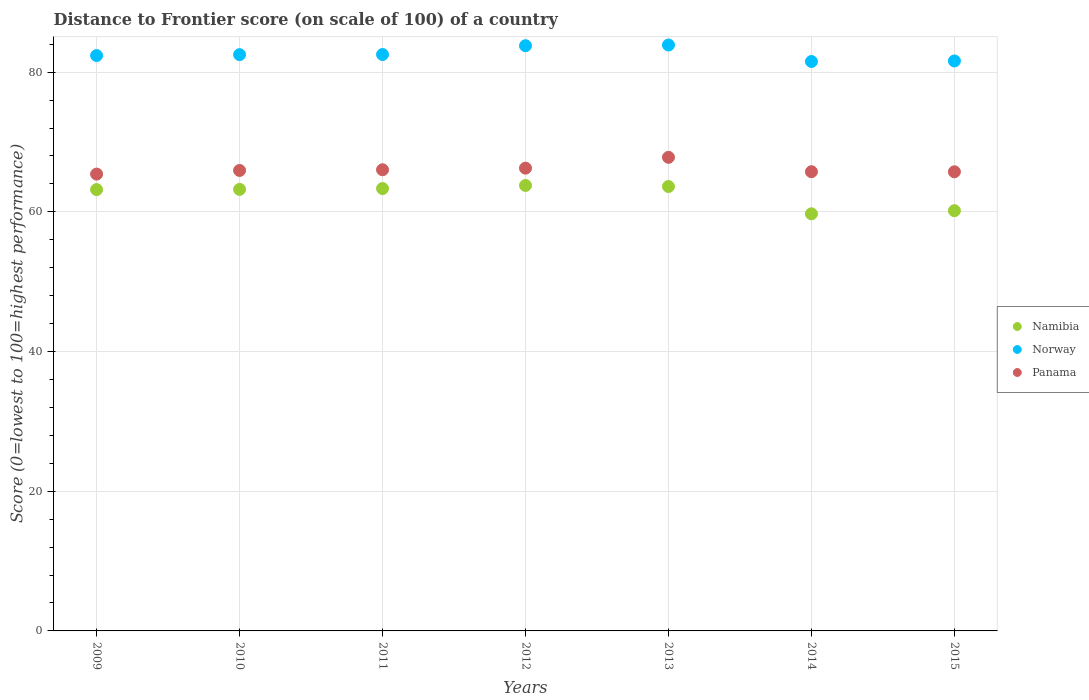How many different coloured dotlines are there?
Provide a succinct answer. 3. Is the number of dotlines equal to the number of legend labels?
Your response must be concise. Yes. What is the distance to frontier score of in Norway in 2013?
Your answer should be compact. 83.89. Across all years, what is the maximum distance to frontier score of in Panama?
Offer a terse response. 67.81. Across all years, what is the minimum distance to frontier score of in Namibia?
Your answer should be compact. 59.72. In which year was the distance to frontier score of in Namibia maximum?
Give a very brief answer. 2012. In which year was the distance to frontier score of in Namibia minimum?
Your answer should be compact. 2014. What is the total distance to frontier score of in Panama in the graph?
Keep it short and to the point. 462.93. What is the difference between the distance to frontier score of in Namibia in 2009 and that in 2015?
Ensure brevity in your answer.  3.02. What is the difference between the distance to frontier score of in Namibia in 2011 and the distance to frontier score of in Norway in 2015?
Ensure brevity in your answer.  -18.27. What is the average distance to frontier score of in Panama per year?
Provide a short and direct response. 66.13. In the year 2015, what is the difference between the distance to frontier score of in Panama and distance to frontier score of in Namibia?
Give a very brief answer. 5.57. What is the ratio of the distance to frontier score of in Norway in 2012 to that in 2013?
Give a very brief answer. 1. Is the difference between the distance to frontier score of in Panama in 2013 and 2014 greater than the difference between the distance to frontier score of in Namibia in 2013 and 2014?
Offer a terse response. No. What is the difference between the highest and the second highest distance to frontier score of in Norway?
Offer a terse response. 0.1. What is the difference between the highest and the lowest distance to frontier score of in Norway?
Offer a terse response. 2.36. In how many years, is the distance to frontier score of in Norway greater than the average distance to frontier score of in Norway taken over all years?
Provide a short and direct response. 2. Is the sum of the distance to frontier score of in Namibia in 2009 and 2010 greater than the maximum distance to frontier score of in Panama across all years?
Your answer should be compact. Yes. Does the distance to frontier score of in Norway monotonically increase over the years?
Give a very brief answer. No. How many dotlines are there?
Offer a very short reply. 3. How many years are there in the graph?
Your response must be concise. 7. Does the graph contain any zero values?
Provide a short and direct response. No. Where does the legend appear in the graph?
Ensure brevity in your answer.  Center right. How many legend labels are there?
Provide a succinct answer. 3. What is the title of the graph?
Provide a succinct answer. Distance to Frontier score (on scale of 100) of a country. What is the label or title of the Y-axis?
Your answer should be very brief. Score (0=lowest to 100=highest performance). What is the Score (0=lowest to 100=highest performance) of Namibia in 2009?
Your answer should be compact. 63.19. What is the Score (0=lowest to 100=highest performance) in Norway in 2009?
Offer a terse response. 82.38. What is the Score (0=lowest to 100=highest performance) in Panama in 2009?
Make the answer very short. 65.41. What is the Score (0=lowest to 100=highest performance) in Namibia in 2010?
Make the answer very short. 63.22. What is the Score (0=lowest to 100=highest performance) in Norway in 2010?
Keep it short and to the point. 82.51. What is the Score (0=lowest to 100=highest performance) in Panama in 2010?
Make the answer very short. 65.93. What is the Score (0=lowest to 100=highest performance) of Namibia in 2011?
Offer a very short reply. 63.34. What is the Score (0=lowest to 100=highest performance) in Norway in 2011?
Keep it short and to the point. 82.53. What is the Score (0=lowest to 100=highest performance) of Panama in 2011?
Offer a very short reply. 66.03. What is the Score (0=lowest to 100=highest performance) of Namibia in 2012?
Offer a terse response. 63.78. What is the Score (0=lowest to 100=highest performance) in Norway in 2012?
Provide a short and direct response. 83.79. What is the Score (0=lowest to 100=highest performance) of Panama in 2012?
Ensure brevity in your answer.  66.26. What is the Score (0=lowest to 100=highest performance) in Namibia in 2013?
Offer a very short reply. 63.63. What is the Score (0=lowest to 100=highest performance) in Norway in 2013?
Provide a short and direct response. 83.89. What is the Score (0=lowest to 100=highest performance) in Panama in 2013?
Offer a very short reply. 67.81. What is the Score (0=lowest to 100=highest performance) of Namibia in 2014?
Ensure brevity in your answer.  59.72. What is the Score (0=lowest to 100=highest performance) of Norway in 2014?
Offer a very short reply. 81.53. What is the Score (0=lowest to 100=highest performance) of Panama in 2014?
Offer a terse response. 65.75. What is the Score (0=lowest to 100=highest performance) of Namibia in 2015?
Keep it short and to the point. 60.17. What is the Score (0=lowest to 100=highest performance) of Norway in 2015?
Provide a succinct answer. 81.61. What is the Score (0=lowest to 100=highest performance) of Panama in 2015?
Provide a succinct answer. 65.74. Across all years, what is the maximum Score (0=lowest to 100=highest performance) in Namibia?
Ensure brevity in your answer.  63.78. Across all years, what is the maximum Score (0=lowest to 100=highest performance) in Norway?
Provide a succinct answer. 83.89. Across all years, what is the maximum Score (0=lowest to 100=highest performance) in Panama?
Ensure brevity in your answer.  67.81. Across all years, what is the minimum Score (0=lowest to 100=highest performance) of Namibia?
Provide a short and direct response. 59.72. Across all years, what is the minimum Score (0=lowest to 100=highest performance) in Norway?
Provide a succinct answer. 81.53. Across all years, what is the minimum Score (0=lowest to 100=highest performance) of Panama?
Provide a short and direct response. 65.41. What is the total Score (0=lowest to 100=highest performance) in Namibia in the graph?
Provide a succinct answer. 437.05. What is the total Score (0=lowest to 100=highest performance) of Norway in the graph?
Ensure brevity in your answer.  578.24. What is the total Score (0=lowest to 100=highest performance) in Panama in the graph?
Provide a short and direct response. 462.93. What is the difference between the Score (0=lowest to 100=highest performance) of Namibia in 2009 and that in 2010?
Keep it short and to the point. -0.03. What is the difference between the Score (0=lowest to 100=highest performance) in Norway in 2009 and that in 2010?
Offer a terse response. -0.13. What is the difference between the Score (0=lowest to 100=highest performance) in Panama in 2009 and that in 2010?
Your response must be concise. -0.52. What is the difference between the Score (0=lowest to 100=highest performance) of Namibia in 2009 and that in 2011?
Ensure brevity in your answer.  -0.15. What is the difference between the Score (0=lowest to 100=highest performance) in Norway in 2009 and that in 2011?
Provide a succinct answer. -0.15. What is the difference between the Score (0=lowest to 100=highest performance) of Panama in 2009 and that in 2011?
Provide a succinct answer. -0.62. What is the difference between the Score (0=lowest to 100=highest performance) of Namibia in 2009 and that in 2012?
Your answer should be compact. -0.59. What is the difference between the Score (0=lowest to 100=highest performance) of Norway in 2009 and that in 2012?
Provide a short and direct response. -1.41. What is the difference between the Score (0=lowest to 100=highest performance) of Panama in 2009 and that in 2012?
Ensure brevity in your answer.  -0.85. What is the difference between the Score (0=lowest to 100=highest performance) of Namibia in 2009 and that in 2013?
Make the answer very short. -0.44. What is the difference between the Score (0=lowest to 100=highest performance) of Norway in 2009 and that in 2013?
Offer a terse response. -1.51. What is the difference between the Score (0=lowest to 100=highest performance) of Panama in 2009 and that in 2013?
Keep it short and to the point. -2.4. What is the difference between the Score (0=lowest to 100=highest performance) in Namibia in 2009 and that in 2014?
Ensure brevity in your answer.  3.47. What is the difference between the Score (0=lowest to 100=highest performance) of Panama in 2009 and that in 2014?
Offer a terse response. -0.34. What is the difference between the Score (0=lowest to 100=highest performance) in Namibia in 2009 and that in 2015?
Ensure brevity in your answer.  3.02. What is the difference between the Score (0=lowest to 100=highest performance) in Norway in 2009 and that in 2015?
Your response must be concise. 0.77. What is the difference between the Score (0=lowest to 100=highest performance) of Panama in 2009 and that in 2015?
Provide a succinct answer. -0.33. What is the difference between the Score (0=lowest to 100=highest performance) in Namibia in 2010 and that in 2011?
Give a very brief answer. -0.12. What is the difference between the Score (0=lowest to 100=highest performance) in Norway in 2010 and that in 2011?
Your answer should be very brief. -0.02. What is the difference between the Score (0=lowest to 100=highest performance) of Namibia in 2010 and that in 2012?
Offer a terse response. -0.56. What is the difference between the Score (0=lowest to 100=highest performance) of Norway in 2010 and that in 2012?
Your answer should be compact. -1.28. What is the difference between the Score (0=lowest to 100=highest performance) of Panama in 2010 and that in 2012?
Offer a very short reply. -0.33. What is the difference between the Score (0=lowest to 100=highest performance) of Namibia in 2010 and that in 2013?
Make the answer very short. -0.41. What is the difference between the Score (0=lowest to 100=highest performance) in Norway in 2010 and that in 2013?
Ensure brevity in your answer.  -1.38. What is the difference between the Score (0=lowest to 100=highest performance) in Panama in 2010 and that in 2013?
Your answer should be very brief. -1.88. What is the difference between the Score (0=lowest to 100=highest performance) in Namibia in 2010 and that in 2014?
Your answer should be compact. 3.5. What is the difference between the Score (0=lowest to 100=highest performance) in Panama in 2010 and that in 2014?
Make the answer very short. 0.18. What is the difference between the Score (0=lowest to 100=highest performance) of Namibia in 2010 and that in 2015?
Give a very brief answer. 3.05. What is the difference between the Score (0=lowest to 100=highest performance) in Norway in 2010 and that in 2015?
Give a very brief answer. 0.9. What is the difference between the Score (0=lowest to 100=highest performance) in Panama in 2010 and that in 2015?
Give a very brief answer. 0.19. What is the difference between the Score (0=lowest to 100=highest performance) of Namibia in 2011 and that in 2012?
Provide a short and direct response. -0.44. What is the difference between the Score (0=lowest to 100=highest performance) of Norway in 2011 and that in 2012?
Ensure brevity in your answer.  -1.26. What is the difference between the Score (0=lowest to 100=highest performance) in Panama in 2011 and that in 2012?
Offer a terse response. -0.23. What is the difference between the Score (0=lowest to 100=highest performance) of Namibia in 2011 and that in 2013?
Your answer should be very brief. -0.29. What is the difference between the Score (0=lowest to 100=highest performance) in Norway in 2011 and that in 2013?
Keep it short and to the point. -1.36. What is the difference between the Score (0=lowest to 100=highest performance) in Panama in 2011 and that in 2013?
Provide a succinct answer. -1.78. What is the difference between the Score (0=lowest to 100=highest performance) of Namibia in 2011 and that in 2014?
Offer a very short reply. 3.62. What is the difference between the Score (0=lowest to 100=highest performance) in Norway in 2011 and that in 2014?
Your answer should be very brief. 1. What is the difference between the Score (0=lowest to 100=highest performance) of Panama in 2011 and that in 2014?
Make the answer very short. 0.28. What is the difference between the Score (0=lowest to 100=highest performance) in Namibia in 2011 and that in 2015?
Ensure brevity in your answer.  3.17. What is the difference between the Score (0=lowest to 100=highest performance) of Panama in 2011 and that in 2015?
Your answer should be compact. 0.29. What is the difference between the Score (0=lowest to 100=highest performance) in Namibia in 2012 and that in 2013?
Offer a terse response. 0.15. What is the difference between the Score (0=lowest to 100=highest performance) in Norway in 2012 and that in 2013?
Offer a very short reply. -0.1. What is the difference between the Score (0=lowest to 100=highest performance) in Panama in 2012 and that in 2013?
Keep it short and to the point. -1.55. What is the difference between the Score (0=lowest to 100=highest performance) in Namibia in 2012 and that in 2014?
Make the answer very short. 4.06. What is the difference between the Score (0=lowest to 100=highest performance) in Norway in 2012 and that in 2014?
Your response must be concise. 2.26. What is the difference between the Score (0=lowest to 100=highest performance) in Panama in 2012 and that in 2014?
Keep it short and to the point. 0.51. What is the difference between the Score (0=lowest to 100=highest performance) of Namibia in 2012 and that in 2015?
Provide a short and direct response. 3.61. What is the difference between the Score (0=lowest to 100=highest performance) of Norway in 2012 and that in 2015?
Make the answer very short. 2.18. What is the difference between the Score (0=lowest to 100=highest performance) in Panama in 2012 and that in 2015?
Offer a very short reply. 0.52. What is the difference between the Score (0=lowest to 100=highest performance) of Namibia in 2013 and that in 2014?
Ensure brevity in your answer.  3.91. What is the difference between the Score (0=lowest to 100=highest performance) of Norway in 2013 and that in 2014?
Give a very brief answer. 2.36. What is the difference between the Score (0=lowest to 100=highest performance) of Panama in 2013 and that in 2014?
Offer a very short reply. 2.06. What is the difference between the Score (0=lowest to 100=highest performance) of Namibia in 2013 and that in 2015?
Offer a very short reply. 3.46. What is the difference between the Score (0=lowest to 100=highest performance) in Norway in 2013 and that in 2015?
Provide a succinct answer. 2.28. What is the difference between the Score (0=lowest to 100=highest performance) of Panama in 2013 and that in 2015?
Your answer should be compact. 2.07. What is the difference between the Score (0=lowest to 100=highest performance) in Namibia in 2014 and that in 2015?
Provide a succinct answer. -0.45. What is the difference between the Score (0=lowest to 100=highest performance) in Norway in 2014 and that in 2015?
Your answer should be compact. -0.08. What is the difference between the Score (0=lowest to 100=highest performance) in Panama in 2014 and that in 2015?
Offer a terse response. 0.01. What is the difference between the Score (0=lowest to 100=highest performance) in Namibia in 2009 and the Score (0=lowest to 100=highest performance) in Norway in 2010?
Keep it short and to the point. -19.32. What is the difference between the Score (0=lowest to 100=highest performance) of Namibia in 2009 and the Score (0=lowest to 100=highest performance) of Panama in 2010?
Your answer should be very brief. -2.74. What is the difference between the Score (0=lowest to 100=highest performance) of Norway in 2009 and the Score (0=lowest to 100=highest performance) of Panama in 2010?
Your answer should be compact. 16.45. What is the difference between the Score (0=lowest to 100=highest performance) in Namibia in 2009 and the Score (0=lowest to 100=highest performance) in Norway in 2011?
Your answer should be compact. -19.34. What is the difference between the Score (0=lowest to 100=highest performance) in Namibia in 2009 and the Score (0=lowest to 100=highest performance) in Panama in 2011?
Provide a succinct answer. -2.84. What is the difference between the Score (0=lowest to 100=highest performance) in Norway in 2009 and the Score (0=lowest to 100=highest performance) in Panama in 2011?
Make the answer very short. 16.35. What is the difference between the Score (0=lowest to 100=highest performance) in Namibia in 2009 and the Score (0=lowest to 100=highest performance) in Norway in 2012?
Provide a short and direct response. -20.6. What is the difference between the Score (0=lowest to 100=highest performance) in Namibia in 2009 and the Score (0=lowest to 100=highest performance) in Panama in 2012?
Ensure brevity in your answer.  -3.07. What is the difference between the Score (0=lowest to 100=highest performance) of Norway in 2009 and the Score (0=lowest to 100=highest performance) of Panama in 2012?
Keep it short and to the point. 16.12. What is the difference between the Score (0=lowest to 100=highest performance) of Namibia in 2009 and the Score (0=lowest to 100=highest performance) of Norway in 2013?
Offer a very short reply. -20.7. What is the difference between the Score (0=lowest to 100=highest performance) of Namibia in 2009 and the Score (0=lowest to 100=highest performance) of Panama in 2013?
Keep it short and to the point. -4.62. What is the difference between the Score (0=lowest to 100=highest performance) in Norway in 2009 and the Score (0=lowest to 100=highest performance) in Panama in 2013?
Make the answer very short. 14.57. What is the difference between the Score (0=lowest to 100=highest performance) of Namibia in 2009 and the Score (0=lowest to 100=highest performance) of Norway in 2014?
Offer a very short reply. -18.34. What is the difference between the Score (0=lowest to 100=highest performance) of Namibia in 2009 and the Score (0=lowest to 100=highest performance) of Panama in 2014?
Provide a short and direct response. -2.56. What is the difference between the Score (0=lowest to 100=highest performance) in Norway in 2009 and the Score (0=lowest to 100=highest performance) in Panama in 2014?
Ensure brevity in your answer.  16.63. What is the difference between the Score (0=lowest to 100=highest performance) in Namibia in 2009 and the Score (0=lowest to 100=highest performance) in Norway in 2015?
Provide a short and direct response. -18.42. What is the difference between the Score (0=lowest to 100=highest performance) in Namibia in 2009 and the Score (0=lowest to 100=highest performance) in Panama in 2015?
Your response must be concise. -2.55. What is the difference between the Score (0=lowest to 100=highest performance) in Norway in 2009 and the Score (0=lowest to 100=highest performance) in Panama in 2015?
Your answer should be compact. 16.64. What is the difference between the Score (0=lowest to 100=highest performance) in Namibia in 2010 and the Score (0=lowest to 100=highest performance) in Norway in 2011?
Your answer should be compact. -19.31. What is the difference between the Score (0=lowest to 100=highest performance) of Namibia in 2010 and the Score (0=lowest to 100=highest performance) of Panama in 2011?
Your response must be concise. -2.81. What is the difference between the Score (0=lowest to 100=highest performance) in Norway in 2010 and the Score (0=lowest to 100=highest performance) in Panama in 2011?
Your answer should be very brief. 16.48. What is the difference between the Score (0=lowest to 100=highest performance) of Namibia in 2010 and the Score (0=lowest to 100=highest performance) of Norway in 2012?
Provide a succinct answer. -20.57. What is the difference between the Score (0=lowest to 100=highest performance) of Namibia in 2010 and the Score (0=lowest to 100=highest performance) of Panama in 2012?
Provide a short and direct response. -3.04. What is the difference between the Score (0=lowest to 100=highest performance) in Norway in 2010 and the Score (0=lowest to 100=highest performance) in Panama in 2012?
Your answer should be very brief. 16.25. What is the difference between the Score (0=lowest to 100=highest performance) in Namibia in 2010 and the Score (0=lowest to 100=highest performance) in Norway in 2013?
Keep it short and to the point. -20.67. What is the difference between the Score (0=lowest to 100=highest performance) in Namibia in 2010 and the Score (0=lowest to 100=highest performance) in Panama in 2013?
Provide a succinct answer. -4.59. What is the difference between the Score (0=lowest to 100=highest performance) in Norway in 2010 and the Score (0=lowest to 100=highest performance) in Panama in 2013?
Provide a short and direct response. 14.7. What is the difference between the Score (0=lowest to 100=highest performance) in Namibia in 2010 and the Score (0=lowest to 100=highest performance) in Norway in 2014?
Offer a terse response. -18.31. What is the difference between the Score (0=lowest to 100=highest performance) of Namibia in 2010 and the Score (0=lowest to 100=highest performance) of Panama in 2014?
Keep it short and to the point. -2.53. What is the difference between the Score (0=lowest to 100=highest performance) in Norway in 2010 and the Score (0=lowest to 100=highest performance) in Panama in 2014?
Your answer should be compact. 16.76. What is the difference between the Score (0=lowest to 100=highest performance) in Namibia in 2010 and the Score (0=lowest to 100=highest performance) in Norway in 2015?
Provide a short and direct response. -18.39. What is the difference between the Score (0=lowest to 100=highest performance) in Namibia in 2010 and the Score (0=lowest to 100=highest performance) in Panama in 2015?
Make the answer very short. -2.52. What is the difference between the Score (0=lowest to 100=highest performance) in Norway in 2010 and the Score (0=lowest to 100=highest performance) in Panama in 2015?
Your answer should be compact. 16.77. What is the difference between the Score (0=lowest to 100=highest performance) in Namibia in 2011 and the Score (0=lowest to 100=highest performance) in Norway in 2012?
Your answer should be compact. -20.45. What is the difference between the Score (0=lowest to 100=highest performance) of Namibia in 2011 and the Score (0=lowest to 100=highest performance) of Panama in 2012?
Offer a very short reply. -2.92. What is the difference between the Score (0=lowest to 100=highest performance) of Norway in 2011 and the Score (0=lowest to 100=highest performance) of Panama in 2012?
Your answer should be very brief. 16.27. What is the difference between the Score (0=lowest to 100=highest performance) of Namibia in 2011 and the Score (0=lowest to 100=highest performance) of Norway in 2013?
Provide a short and direct response. -20.55. What is the difference between the Score (0=lowest to 100=highest performance) of Namibia in 2011 and the Score (0=lowest to 100=highest performance) of Panama in 2013?
Offer a terse response. -4.47. What is the difference between the Score (0=lowest to 100=highest performance) of Norway in 2011 and the Score (0=lowest to 100=highest performance) of Panama in 2013?
Your answer should be very brief. 14.72. What is the difference between the Score (0=lowest to 100=highest performance) in Namibia in 2011 and the Score (0=lowest to 100=highest performance) in Norway in 2014?
Your response must be concise. -18.19. What is the difference between the Score (0=lowest to 100=highest performance) of Namibia in 2011 and the Score (0=lowest to 100=highest performance) of Panama in 2014?
Provide a succinct answer. -2.41. What is the difference between the Score (0=lowest to 100=highest performance) of Norway in 2011 and the Score (0=lowest to 100=highest performance) of Panama in 2014?
Keep it short and to the point. 16.78. What is the difference between the Score (0=lowest to 100=highest performance) in Namibia in 2011 and the Score (0=lowest to 100=highest performance) in Norway in 2015?
Offer a very short reply. -18.27. What is the difference between the Score (0=lowest to 100=highest performance) in Norway in 2011 and the Score (0=lowest to 100=highest performance) in Panama in 2015?
Keep it short and to the point. 16.79. What is the difference between the Score (0=lowest to 100=highest performance) of Namibia in 2012 and the Score (0=lowest to 100=highest performance) of Norway in 2013?
Provide a succinct answer. -20.11. What is the difference between the Score (0=lowest to 100=highest performance) of Namibia in 2012 and the Score (0=lowest to 100=highest performance) of Panama in 2013?
Provide a short and direct response. -4.03. What is the difference between the Score (0=lowest to 100=highest performance) of Norway in 2012 and the Score (0=lowest to 100=highest performance) of Panama in 2013?
Keep it short and to the point. 15.98. What is the difference between the Score (0=lowest to 100=highest performance) of Namibia in 2012 and the Score (0=lowest to 100=highest performance) of Norway in 2014?
Make the answer very short. -17.75. What is the difference between the Score (0=lowest to 100=highest performance) of Namibia in 2012 and the Score (0=lowest to 100=highest performance) of Panama in 2014?
Offer a terse response. -1.97. What is the difference between the Score (0=lowest to 100=highest performance) of Norway in 2012 and the Score (0=lowest to 100=highest performance) of Panama in 2014?
Offer a terse response. 18.04. What is the difference between the Score (0=lowest to 100=highest performance) in Namibia in 2012 and the Score (0=lowest to 100=highest performance) in Norway in 2015?
Make the answer very short. -17.83. What is the difference between the Score (0=lowest to 100=highest performance) in Namibia in 2012 and the Score (0=lowest to 100=highest performance) in Panama in 2015?
Keep it short and to the point. -1.96. What is the difference between the Score (0=lowest to 100=highest performance) in Norway in 2012 and the Score (0=lowest to 100=highest performance) in Panama in 2015?
Ensure brevity in your answer.  18.05. What is the difference between the Score (0=lowest to 100=highest performance) of Namibia in 2013 and the Score (0=lowest to 100=highest performance) of Norway in 2014?
Offer a very short reply. -17.9. What is the difference between the Score (0=lowest to 100=highest performance) in Namibia in 2013 and the Score (0=lowest to 100=highest performance) in Panama in 2014?
Provide a succinct answer. -2.12. What is the difference between the Score (0=lowest to 100=highest performance) of Norway in 2013 and the Score (0=lowest to 100=highest performance) of Panama in 2014?
Offer a terse response. 18.14. What is the difference between the Score (0=lowest to 100=highest performance) in Namibia in 2013 and the Score (0=lowest to 100=highest performance) in Norway in 2015?
Offer a terse response. -17.98. What is the difference between the Score (0=lowest to 100=highest performance) of Namibia in 2013 and the Score (0=lowest to 100=highest performance) of Panama in 2015?
Provide a short and direct response. -2.11. What is the difference between the Score (0=lowest to 100=highest performance) in Norway in 2013 and the Score (0=lowest to 100=highest performance) in Panama in 2015?
Provide a short and direct response. 18.15. What is the difference between the Score (0=lowest to 100=highest performance) of Namibia in 2014 and the Score (0=lowest to 100=highest performance) of Norway in 2015?
Offer a very short reply. -21.89. What is the difference between the Score (0=lowest to 100=highest performance) of Namibia in 2014 and the Score (0=lowest to 100=highest performance) of Panama in 2015?
Keep it short and to the point. -6.02. What is the difference between the Score (0=lowest to 100=highest performance) of Norway in 2014 and the Score (0=lowest to 100=highest performance) of Panama in 2015?
Provide a succinct answer. 15.79. What is the average Score (0=lowest to 100=highest performance) in Namibia per year?
Make the answer very short. 62.44. What is the average Score (0=lowest to 100=highest performance) in Norway per year?
Ensure brevity in your answer.  82.61. What is the average Score (0=lowest to 100=highest performance) in Panama per year?
Give a very brief answer. 66.13. In the year 2009, what is the difference between the Score (0=lowest to 100=highest performance) of Namibia and Score (0=lowest to 100=highest performance) of Norway?
Keep it short and to the point. -19.19. In the year 2009, what is the difference between the Score (0=lowest to 100=highest performance) in Namibia and Score (0=lowest to 100=highest performance) in Panama?
Your answer should be very brief. -2.22. In the year 2009, what is the difference between the Score (0=lowest to 100=highest performance) in Norway and Score (0=lowest to 100=highest performance) in Panama?
Provide a succinct answer. 16.97. In the year 2010, what is the difference between the Score (0=lowest to 100=highest performance) of Namibia and Score (0=lowest to 100=highest performance) of Norway?
Your answer should be compact. -19.29. In the year 2010, what is the difference between the Score (0=lowest to 100=highest performance) of Namibia and Score (0=lowest to 100=highest performance) of Panama?
Give a very brief answer. -2.71. In the year 2010, what is the difference between the Score (0=lowest to 100=highest performance) of Norway and Score (0=lowest to 100=highest performance) of Panama?
Your answer should be compact. 16.58. In the year 2011, what is the difference between the Score (0=lowest to 100=highest performance) in Namibia and Score (0=lowest to 100=highest performance) in Norway?
Ensure brevity in your answer.  -19.19. In the year 2011, what is the difference between the Score (0=lowest to 100=highest performance) in Namibia and Score (0=lowest to 100=highest performance) in Panama?
Offer a terse response. -2.69. In the year 2012, what is the difference between the Score (0=lowest to 100=highest performance) in Namibia and Score (0=lowest to 100=highest performance) in Norway?
Your answer should be very brief. -20.01. In the year 2012, what is the difference between the Score (0=lowest to 100=highest performance) of Namibia and Score (0=lowest to 100=highest performance) of Panama?
Give a very brief answer. -2.48. In the year 2012, what is the difference between the Score (0=lowest to 100=highest performance) of Norway and Score (0=lowest to 100=highest performance) of Panama?
Make the answer very short. 17.53. In the year 2013, what is the difference between the Score (0=lowest to 100=highest performance) in Namibia and Score (0=lowest to 100=highest performance) in Norway?
Give a very brief answer. -20.26. In the year 2013, what is the difference between the Score (0=lowest to 100=highest performance) in Namibia and Score (0=lowest to 100=highest performance) in Panama?
Your answer should be compact. -4.18. In the year 2013, what is the difference between the Score (0=lowest to 100=highest performance) in Norway and Score (0=lowest to 100=highest performance) in Panama?
Your answer should be compact. 16.08. In the year 2014, what is the difference between the Score (0=lowest to 100=highest performance) in Namibia and Score (0=lowest to 100=highest performance) in Norway?
Your response must be concise. -21.81. In the year 2014, what is the difference between the Score (0=lowest to 100=highest performance) of Namibia and Score (0=lowest to 100=highest performance) of Panama?
Make the answer very short. -6.03. In the year 2014, what is the difference between the Score (0=lowest to 100=highest performance) of Norway and Score (0=lowest to 100=highest performance) of Panama?
Offer a terse response. 15.78. In the year 2015, what is the difference between the Score (0=lowest to 100=highest performance) of Namibia and Score (0=lowest to 100=highest performance) of Norway?
Keep it short and to the point. -21.44. In the year 2015, what is the difference between the Score (0=lowest to 100=highest performance) of Namibia and Score (0=lowest to 100=highest performance) of Panama?
Offer a terse response. -5.57. In the year 2015, what is the difference between the Score (0=lowest to 100=highest performance) in Norway and Score (0=lowest to 100=highest performance) in Panama?
Make the answer very short. 15.87. What is the ratio of the Score (0=lowest to 100=highest performance) of Norway in 2009 to that in 2010?
Ensure brevity in your answer.  1. What is the ratio of the Score (0=lowest to 100=highest performance) in Panama in 2009 to that in 2010?
Make the answer very short. 0.99. What is the ratio of the Score (0=lowest to 100=highest performance) of Panama in 2009 to that in 2011?
Your answer should be compact. 0.99. What is the ratio of the Score (0=lowest to 100=highest performance) in Namibia in 2009 to that in 2012?
Give a very brief answer. 0.99. What is the ratio of the Score (0=lowest to 100=highest performance) of Norway in 2009 to that in 2012?
Make the answer very short. 0.98. What is the ratio of the Score (0=lowest to 100=highest performance) of Panama in 2009 to that in 2012?
Your answer should be compact. 0.99. What is the ratio of the Score (0=lowest to 100=highest performance) of Norway in 2009 to that in 2013?
Your response must be concise. 0.98. What is the ratio of the Score (0=lowest to 100=highest performance) of Panama in 2009 to that in 2013?
Keep it short and to the point. 0.96. What is the ratio of the Score (0=lowest to 100=highest performance) of Namibia in 2009 to that in 2014?
Your answer should be compact. 1.06. What is the ratio of the Score (0=lowest to 100=highest performance) in Norway in 2009 to that in 2014?
Your answer should be very brief. 1.01. What is the ratio of the Score (0=lowest to 100=highest performance) of Panama in 2009 to that in 2014?
Offer a terse response. 0.99. What is the ratio of the Score (0=lowest to 100=highest performance) of Namibia in 2009 to that in 2015?
Provide a short and direct response. 1.05. What is the ratio of the Score (0=lowest to 100=highest performance) of Norway in 2009 to that in 2015?
Keep it short and to the point. 1.01. What is the ratio of the Score (0=lowest to 100=highest performance) of Panama in 2009 to that in 2015?
Keep it short and to the point. 0.99. What is the ratio of the Score (0=lowest to 100=highest performance) in Norway in 2010 to that in 2011?
Your response must be concise. 1. What is the ratio of the Score (0=lowest to 100=highest performance) of Panama in 2010 to that in 2011?
Keep it short and to the point. 1. What is the ratio of the Score (0=lowest to 100=highest performance) in Namibia in 2010 to that in 2012?
Keep it short and to the point. 0.99. What is the ratio of the Score (0=lowest to 100=highest performance) of Norway in 2010 to that in 2012?
Ensure brevity in your answer.  0.98. What is the ratio of the Score (0=lowest to 100=highest performance) in Panama in 2010 to that in 2012?
Your answer should be very brief. 0.99. What is the ratio of the Score (0=lowest to 100=highest performance) of Namibia in 2010 to that in 2013?
Ensure brevity in your answer.  0.99. What is the ratio of the Score (0=lowest to 100=highest performance) of Norway in 2010 to that in 2013?
Offer a terse response. 0.98. What is the ratio of the Score (0=lowest to 100=highest performance) in Panama in 2010 to that in 2013?
Offer a terse response. 0.97. What is the ratio of the Score (0=lowest to 100=highest performance) in Namibia in 2010 to that in 2014?
Offer a very short reply. 1.06. What is the ratio of the Score (0=lowest to 100=highest performance) of Panama in 2010 to that in 2014?
Provide a succinct answer. 1. What is the ratio of the Score (0=lowest to 100=highest performance) in Namibia in 2010 to that in 2015?
Make the answer very short. 1.05. What is the ratio of the Score (0=lowest to 100=highest performance) in Norway in 2010 to that in 2015?
Offer a very short reply. 1.01. What is the ratio of the Score (0=lowest to 100=highest performance) of Panama in 2010 to that in 2015?
Provide a succinct answer. 1. What is the ratio of the Score (0=lowest to 100=highest performance) of Norway in 2011 to that in 2012?
Offer a terse response. 0.98. What is the ratio of the Score (0=lowest to 100=highest performance) in Panama in 2011 to that in 2012?
Keep it short and to the point. 1. What is the ratio of the Score (0=lowest to 100=highest performance) in Norway in 2011 to that in 2013?
Ensure brevity in your answer.  0.98. What is the ratio of the Score (0=lowest to 100=highest performance) of Panama in 2011 to that in 2013?
Your answer should be very brief. 0.97. What is the ratio of the Score (0=lowest to 100=highest performance) in Namibia in 2011 to that in 2014?
Provide a succinct answer. 1.06. What is the ratio of the Score (0=lowest to 100=highest performance) of Norway in 2011 to that in 2014?
Give a very brief answer. 1.01. What is the ratio of the Score (0=lowest to 100=highest performance) in Panama in 2011 to that in 2014?
Make the answer very short. 1. What is the ratio of the Score (0=lowest to 100=highest performance) of Namibia in 2011 to that in 2015?
Your response must be concise. 1.05. What is the ratio of the Score (0=lowest to 100=highest performance) of Norway in 2011 to that in 2015?
Ensure brevity in your answer.  1.01. What is the ratio of the Score (0=lowest to 100=highest performance) in Panama in 2011 to that in 2015?
Provide a succinct answer. 1. What is the ratio of the Score (0=lowest to 100=highest performance) of Norway in 2012 to that in 2013?
Provide a succinct answer. 1. What is the ratio of the Score (0=lowest to 100=highest performance) of Panama in 2012 to that in 2013?
Your answer should be compact. 0.98. What is the ratio of the Score (0=lowest to 100=highest performance) in Namibia in 2012 to that in 2014?
Your response must be concise. 1.07. What is the ratio of the Score (0=lowest to 100=highest performance) in Norway in 2012 to that in 2014?
Your answer should be compact. 1.03. What is the ratio of the Score (0=lowest to 100=highest performance) in Namibia in 2012 to that in 2015?
Your answer should be very brief. 1.06. What is the ratio of the Score (0=lowest to 100=highest performance) in Norway in 2012 to that in 2015?
Keep it short and to the point. 1.03. What is the ratio of the Score (0=lowest to 100=highest performance) in Panama in 2012 to that in 2015?
Your answer should be compact. 1.01. What is the ratio of the Score (0=lowest to 100=highest performance) of Namibia in 2013 to that in 2014?
Make the answer very short. 1.07. What is the ratio of the Score (0=lowest to 100=highest performance) in Norway in 2013 to that in 2014?
Provide a short and direct response. 1.03. What is the ratio of the Score (0=lowest to 100=highest performance) of Panama in 2013 to that in 2014?
Keep it short and to the point. 1.03. What is the ratio of the Score (0=lowest to 100=highest performance) in Namibia in 2013 to that in 2015?
Keep it short and to the point. 1.06. What is the ratio of the Score (0=lowest to 100=highest performance) in Norway in 2013 to that in 2015?
Offer a very short reply. 1.03. What is the ratio of the Score (0=lowest to 100=highest performance) of Panama in 2013 to that in 2015?
Offer a terse response. 1.03. What is the ratio of the Score (0=lowest to 100=highest performance) of Norway in 2014 to that in 2015?
Offer a very short reply. 1. What is the ratio of the Score (0=lowest to 100=highest performance) of Panama in 2014 to that in 2015?
Give a very brief answer. 1. What is the difference between the highest and the second highest Score (0=lowest to 100=highest performance) of Panama?
Provide a succinct answer. 1.55. What is the difference between the highest and the lowest Score (0=lowest to 100=highest performance) in Namibia?
Provide a succinct answer. 4.06. What is the difference between the highest and the lowest Score (0=lowest to 100=highest performance) of Norway?
Provide a succinct answer. 2.36. 